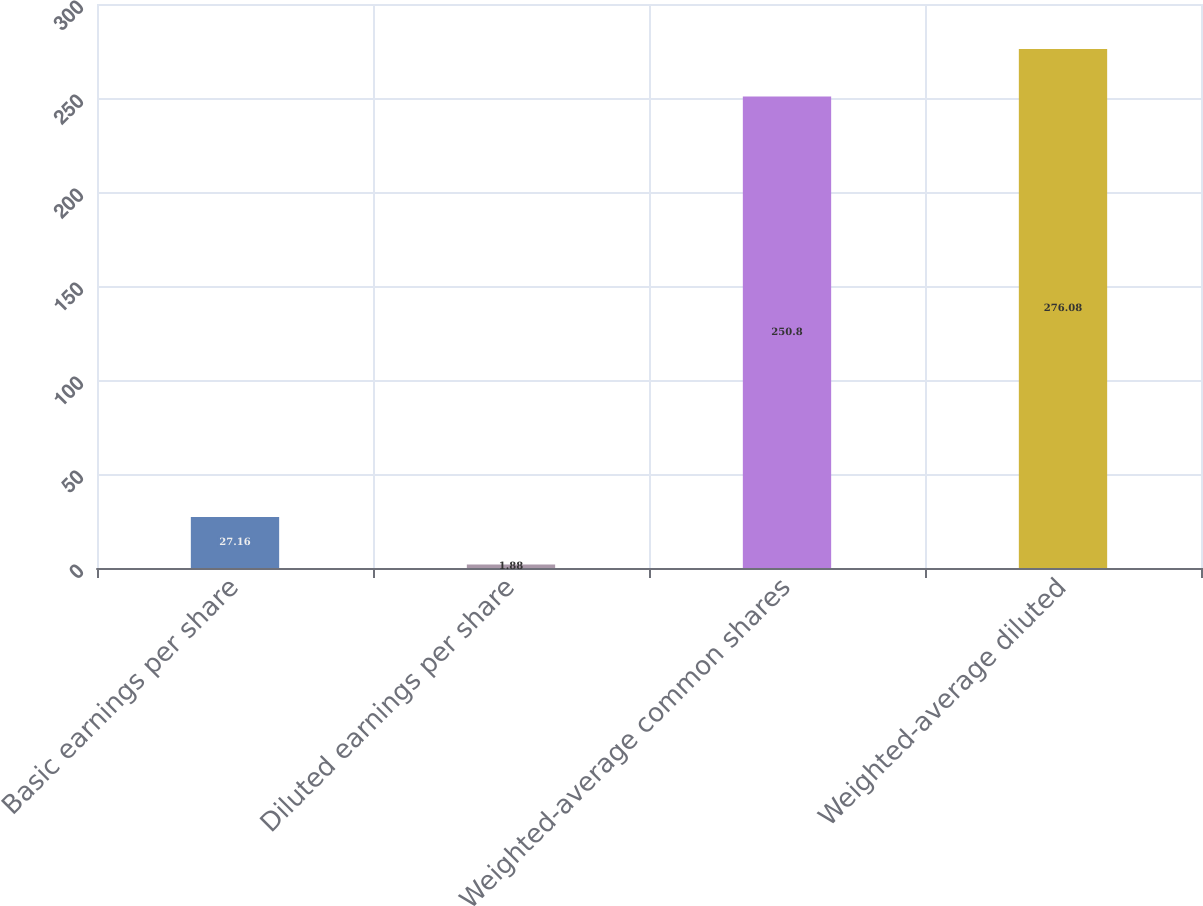Convert chart. <chart><loc_0><loc_0><loc_500><loc_500><bar_chart><fcel>Basic earnings per share<fcel>Diluted earnings per share<fcel>Weighted-average common shares<fcel>Weighted-average diluted<nl><fcel>27.16<fcel>1.88<fcel>250.8<fcel>276.08<nl></chart> 